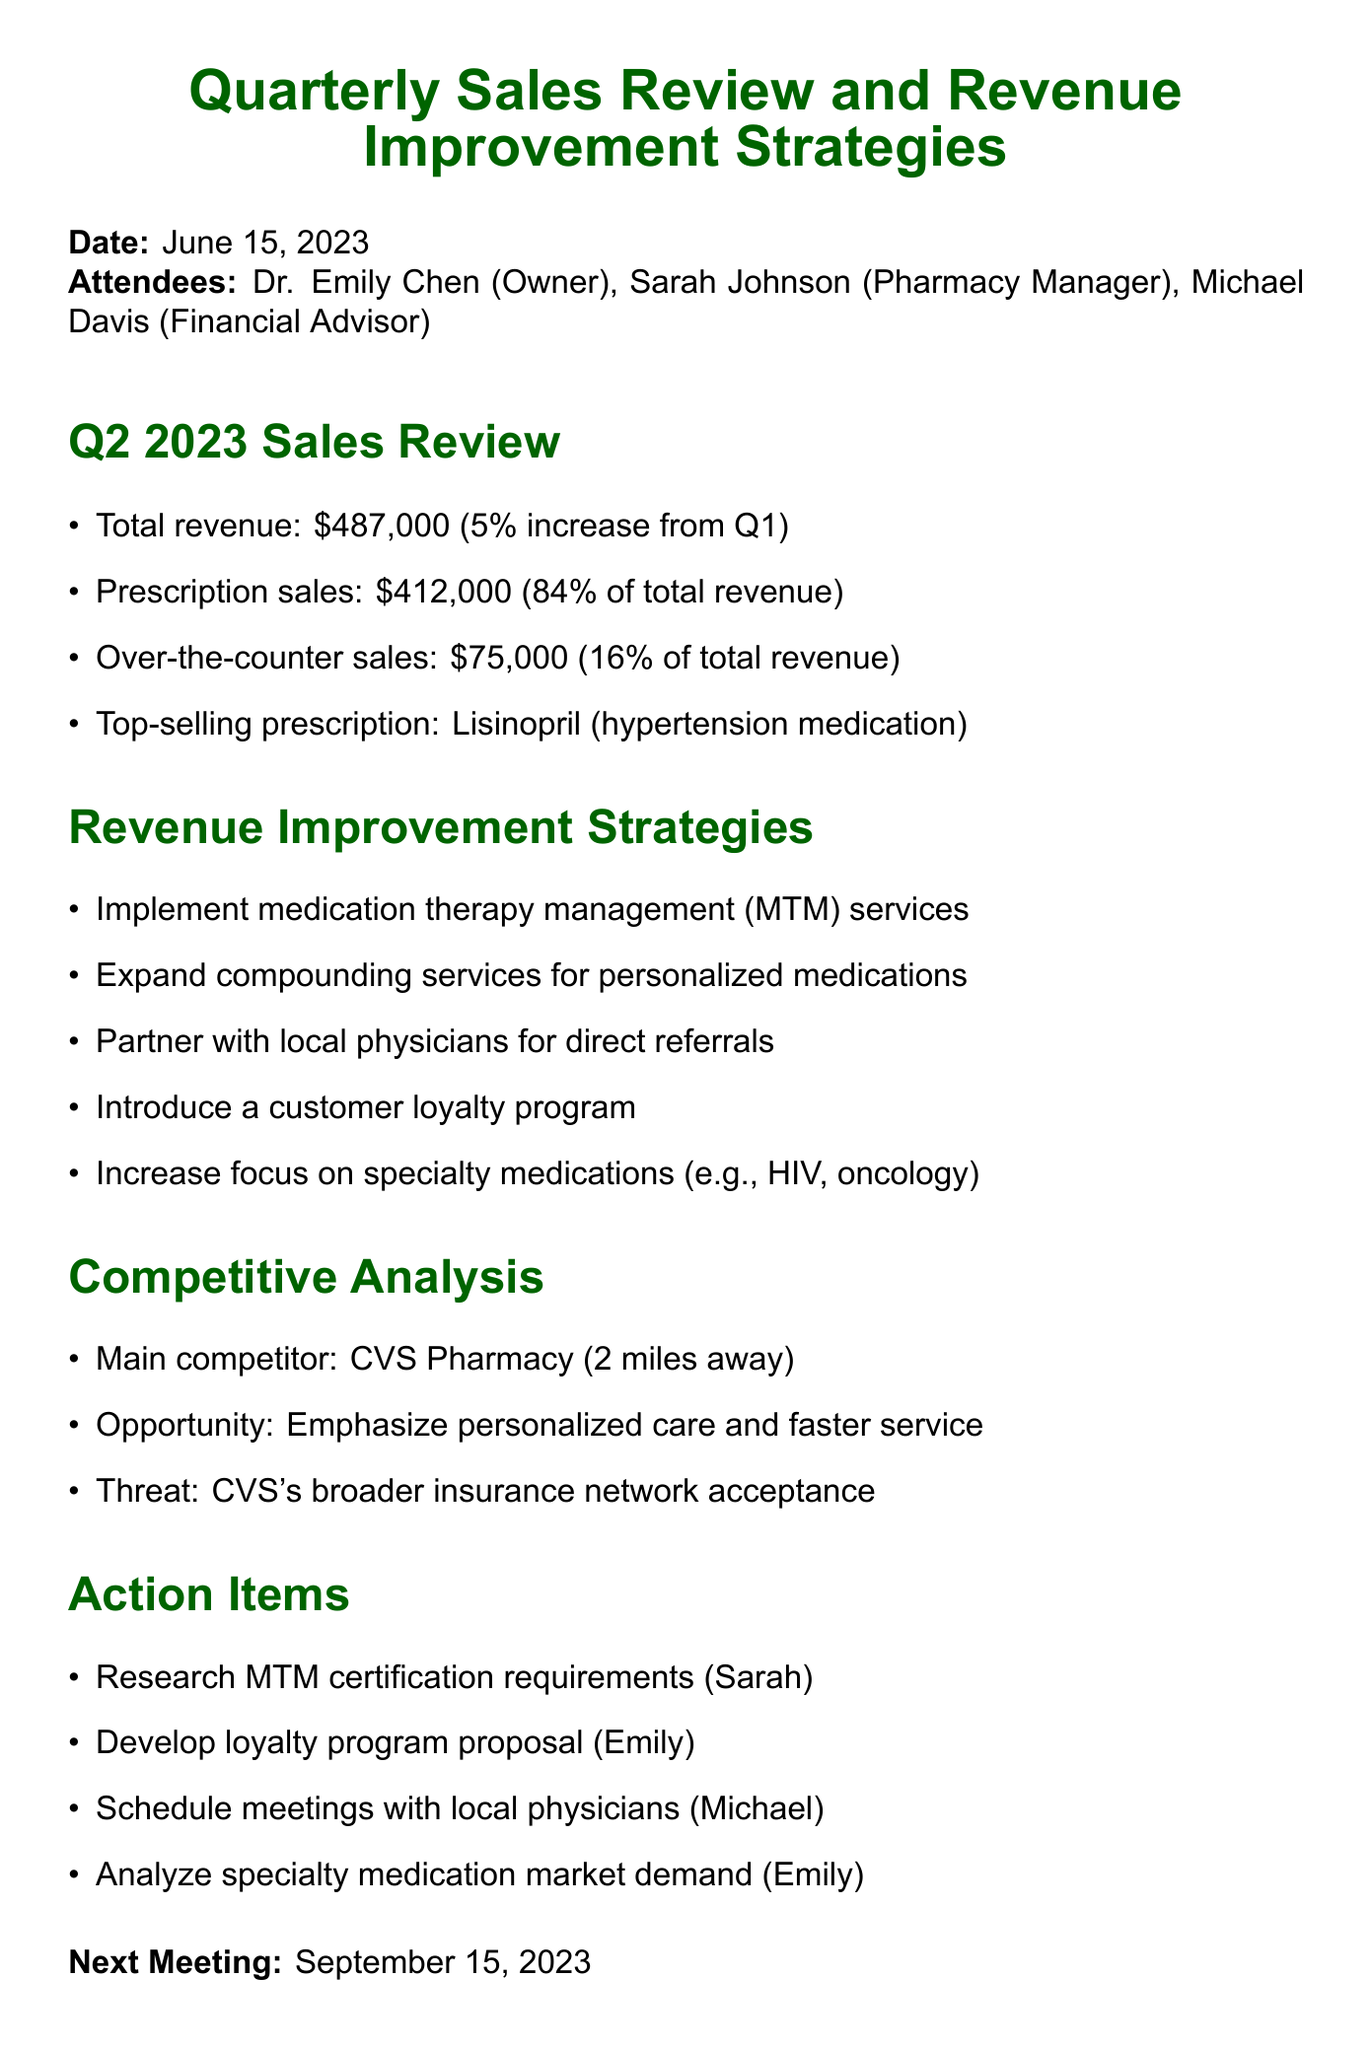What was the total revenue for Q2 2023? The total revenue is noted in the document as being $487,000 for Q2 2023.
Answer: $487,000 What percentage of total revenue came from prescription sales? The document specifies that prescription sales accounted for 84% of the total revenue.
Answer: 84% What is the next meeting date? The document clearly states that the next meeting is scheduled for September 15, 2023.
Answer: September 15, 2023 What are the top-selling prescription mentioned? The document highlights Lisinopril as the top-selling prescription.
Answer: Lisinopril What strategy involves working with local healthcare providers? The document mentions partnering with local physicians for direct referrals as a strategy to improve revenue.
Answer: Partner with local physicians How does the pharmacy plan to compete with CVS Pharmacy? The document notes that the emphasis on personalized care and faster service represent the pharmacy's competitive advantage over CVS.
Answer: Emphasize personalized care and faster service Who is responsible for researching MTM certification requirements? The action item specifies that Sarah is tasked with researching MTM certification requirements.
Answer: Sarah What is one of the proposed revenue improvement strategies? The document lists multiple strategies, including the implementation of medication therapy management services as a revenue improvement strategy.
Answer: Implement medication therapy management (MTM) services 